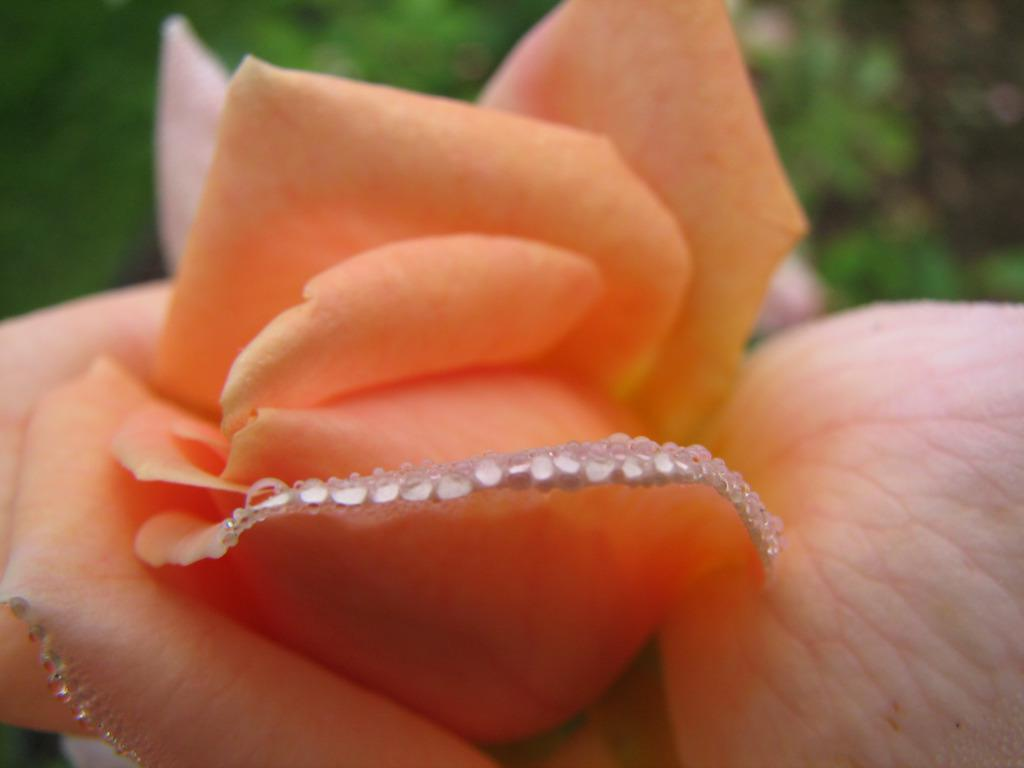What type of flower is in the picture? There is an orange rose in the picture. How many toothbrushes are visible in the picture? There are no toothbrushes present in the picture; it features an orange rose. What type of sound does the plough make in the picture? There is no plough present in the picture, so it is not possible to determine the sound it might make. 